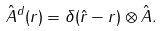<formula> <loc_0><loc_0><loc_500><loc_500>\hat { A } ^ { d } ( { r } ) = \delta ( \hat { r } - { r } ) \otimes \hat { A } .</formula> 